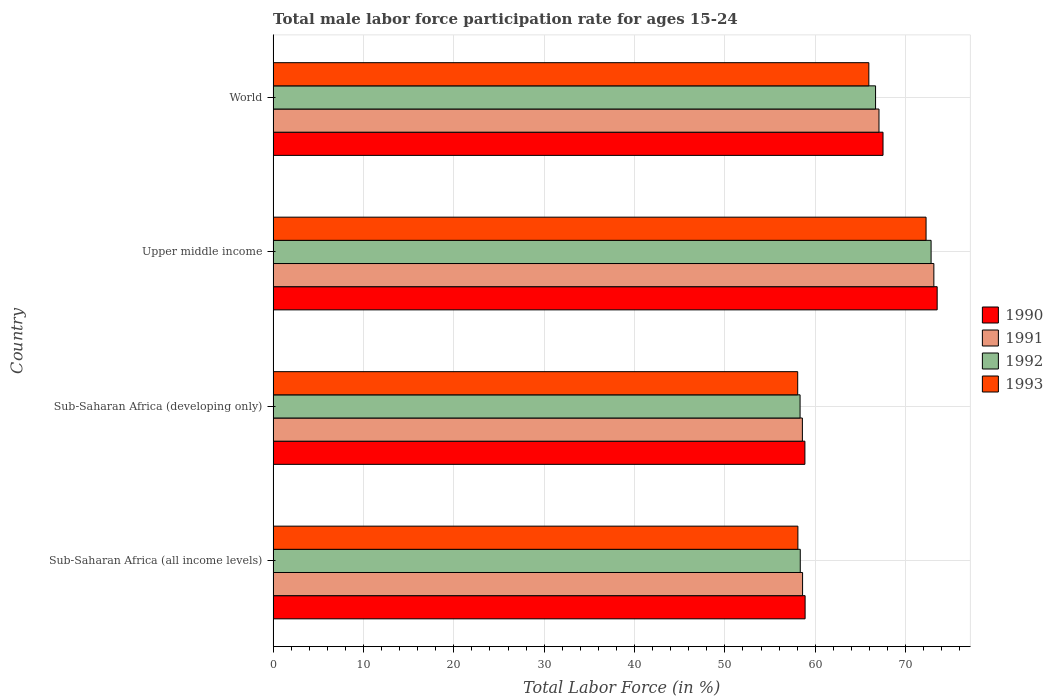How many different coloured bars are there?
Your answer should be very brief. 4. How many groups of bars are there?
Ensure brevity in your answer.  4. Are the number of bars per tick equal to the number of legend labels?
Offer a terse response. Yes. Are the number of bars on each tick of the Y-axis equal?
Your answer should be compact. Yes. How many bars are there on the 1st tick from the top?
Make the answer very short. 4. How many bars are there on the 4th tick from the bottom?
Offer a very short reply. 4. What is the male labor force participation rate in 1990 in Sub-Saharan Africa (all income levels)?
Provide a short and direct response. 58.88. Across all countries, what is the maximum male labor force participation rate in 1990?
Provide a short and direct response. 73.49. Across all countries, what is the minimum male labor force participation rate in 1991?
Keep it short and to the point. 58.57. In which country was the male labor force participation rate in 1993 maximum?
Keep it short and to the point. Upper middle income. In which country was the male labor force participation rate in 1990 minimum?
Keep it short and to the point. Sub-Saharan Africa (developing only). What is the total male labor force participation rate in 1990 in the graph?
Your response must be concise. 258.72. What is the difference between the male labor force participation rate in 1991 in Sub-Saharan Africa (developing only) and that in World?
Provide a succinct answer. -8.48. What is the difference between the male labor force participation rate in 1993 in Sub-Saharan Africa (all income levels) and the male labor force participation rate in 1991 in Upper middle income?
Provide a succinct answer. -15.05. What is the average male labor force participation rate in 1991 per country?
Give a very brief answer. 64.34. What is the difference between the male labor force participation rate in 1990 and male labor force participation rate in 1993 in Sub-Saharan Africa (developing only)?
Ensure brevity in your answer.  0.8. In how many countries, is the male labor force participation rate in 1991 greater than 52 %?
Offer a very short reply. 4. What is the ratio of the male labor force participation rate in 1993 in Sub-Saharan Africa (all income levels) to that in World?
Make the answer very short. 0.88. Is the male labor force participation rate in 1991 in Sub-Saharan Africa (developing only) less than that in World?
Give a very brief answer. Yes. Is the difference between the male labor force participation rate in 1990 in Sub-Saharan Africa (developing only) and World greater than the difference between the male labor force participation rate in 1993 in Sub-Saharan Africa (developing only) and World?
Provide a succinct answer. No. What is the difference between the highest and the second highest male labor force participation rate in 1991?
Give a very brief answer. 6.07. What is the difference between the highest and the lowest male labor force participation rate in 1991?
Give a very brief answer. 14.55. In how many countries, is the male labor force participation rate in 1990 greater than the average male labor force participation rate in 1990 taken over all countries?
Give a very brief answer. 2. What does the 2nd bar from the top in Sub-Saharan Africa (developing only) represents?
Provide a succinct answer. 1992. What does the 2nd bar from the bottom in Sub-Saharan Africa (all income levels) represents?
Make the answer very short. 1991. Is it the case that in every country, the sum of the male labor force participation rate in 1992 and male labor force participation rate in 1991 is greater than the male labor force participation rate in 1990?
Provide a succinct answer. Yes. How many bars are there?
Ensure brevity in your answer.  16. Are all the bars in the graph horizontal?
Offer a very short reply. Yes. How many countries are there in the graph?
Provide a succinct answer. 4. Are the values on the major ticks of X-axis written in scientific E-notation?
Ensure brevity in your answer.  No. How are the legend labels stacked?
Your response must be concise. Vertical. What is the title of the graph?
Make the answer very short. Total male labor force participation rate for ages 15-24. What is the label or title of the X-axis?
Offer a very short reply. Total Labor Force (in %). What is the label or title of the Y-axis?
Make the answer very short. Country. What is the Total Labor Force (in %) in 1990 in Sub-Saharan Africa (all income levels)?
Keep it short and to the point. 58.88. What is the Total Labor Force (in %) of 1991 in Sub-Saharan Africa (all income levels)?
Your answer should be compact. 58.6. What is the Total Labor Force (in %) of 1992 in Sub-Saharan Africa (all income levels)?
Keep it short and to the point. 58.34. What is the Total Labor Force (in %) of 1993 in Sub-Saharan Africa (all income levels)?
Your answer should be very brief. 58.08. What is the Total Labor Force (in %) in 1990 in Sub-Saharan Africa (developing only)?
Your answer should be very brief. 58.85. What is the Total Labor Force (in %) of 1991 in Sub-Saharan Africa (developing only)?
Your response must be concise. 58.57. What is the Total Labor Force (in %) in 1992 in Sub-Saharan Africa (developing only)?
Your answer should be very brief. 58.32. What is the Total Labor Force (in %) of 1993 in Sub-Saharan Africa (developing only)?
Offer a terse response. 58.06. What is the Total Labor Force (in %) of 1990 in Upper middle income?
Your answer should be very brief. 73.49. What is the Total Labor Force (in %) in 1991 in Upper middle income?
Provide a short and direct response. 73.13. What is the Total Labor Force (in %) of 1992 in Upper middle income?
Your answer should be compact. 72.82. What is the Total Labor Force (in %) in 1993 in Upper middle income?
Provide a succinct answer. 72.26. What is the Total Labor Force (in %) of 1990 in World?
Provide a short and direct response. 67.5. What is the Total Labor Force (in %) of 1991 in World?
Keep it short and to the point. 67.05. What is the Total Labor Force (in %) of 1992 in World?
Your answer should be very brief. 66.67. What is the Total Labor Force (in %) of 1993 in World?
Offer a terse response. 65.93. Across all countries, what is the maximum Total Labor Force (in %) of 1990?
Your response must be concise. 73.49. Across all countries, what is the maximum Total Labor Force (in %) in 1991?
Your response must be concise. 73.13. Across all countries, what is the maximum Total Labor Force (in %) in 1992?
Your answer should be very brief. 72.82. Across all countries, what is the maximum Total Labor Force (in %) in 1993?
Make the answer very short. 72.26. Across all countries, what is the minimum Total Labor Force (in %) in 1990?
Offer a terse response. 58.85. Across all countries, what is the minimum Total Labor Force (in %) of 1991?
Provide a succinct answer. 58.57. Across all countries, what is the minimum Total Labor Force (in %) of 1992?
Give a very brief answer. 58.32. Across all countries, what is the minimum Total Labor Force (in %) in 1993?
Offer a very short reply. 58.06. What is the total Total Labor Force (in %) of 1990 in the graph?
Offer a terse response. 258.72. What is the total Total Labor Force (in %) of 1991 in the graph?
Offer a terse response. 257.35. What is the total Total Labor Force (in %) of 1992 in the graph?
Keep it short and to the point. 256.15. What is the total Total Labor Force (in %) of 1993 in the graph?
Offer a very short reply. 254.33. What is the difference between the Total Labor Force (in %) of 1990 in Sub-Saharan Africa (all income levels) and that in Sub-Saharan Africa (developing only)?
Make the answer very short. 0.02. What is the difference between the Total Labor Force (in %) of 1991 in Sub-Saharan Africa (all income levels) and that in Sub-Saharan Africa (developing only)?
Keep it short and to the point. 0.02. What is the difference between the Total Labor Force (in %) in 1992 in Sub-Saharan Africa (all income levels) and that in Sub-Saharan Africa (developing only)?
Offer a very short reply. 0.02. What is the difference between the Total Labor Force (in %) of 1993 in Sub-Saharan Africa (all income levels) and that in Sub-Saharan Africa (developing only)?
Make the answer very short. 0.02. What is the difference between the Total Labor Force (in %) in 1990 in Sub-Saharan Africa (all income levels) and that in Upper middle income?
Provide a short and direct response. -14.62. What is the difference between the Total Labor Force (in %) in 1991 in Sub-Saharan Africa (all income levels) and that in Upper middle income?
Ensure brevity in your answer.  -14.53. What is the difference between the Total Labor Force (in %) of 1992 in Sub-Saharan Africa (all income levels) and that in Upper middle income?
Offer a very short reply. -14.48. What is the difference between the Total Labor Force (in %) of 1993 in Sub-Saharan Africa (all income levels) and that in Upper middle income?
Provide a short and direct response. -14.19. What is the difference between the Total Labor Force (in %) in 1990 in Sub-Saharan Africa (all income levels) and that in World?
Your answer should be compact. -8.62. What is the difference between the Total Labor Force (in %) of 1991 in Sub-Saharan Africa (all income levels) and that in World?
Your response must be concise. -8.46. What is the difference between the Total Labor Force (in %) in 1992 in Sub-Saharan Africa (all income levels) and that in World?
Your answer should be very brief. -8.33. What is the difference between the Total Labor Force (in %) of 1993 in Sub-Saharan Africa (all income levels) and that in World?
Keep it short and to the point. -7.85. What is the difference between the Total Labor Force (in %) in 1990 in Sub-Saharan Africa (developing only) and that in Upper middle income?
Give a very brief answer. -14.64. What is the difference between the Total Labor Force (in %) in 1991 in Sub-Saharan Africa (developing only) and that in Upper middle income?
Provide a succinct answer. -14.55. What is the difference between the Total Labor Force (in %) in 1992 in Sub-Saharan Africa (developing only) and that in Upper middle income?
Your answer should be compact. -14.5. What is the difference between the Total Labor Force (in %) of 1993 in Sub-Saharan Africa (developing only) and that in Upper middle income?
Ensure brevity in your answer.  -14.21. What is the difference between the Total Labor Force (in %) in 1990 in Sub-Saharan Africa (developing only) and that in World?
Your answer should be compact. -8.65. What is the difference between the Total Labor Force (in %) of 1991 in Sub-Saharan Africa (developing only) and that in World?
Provide a succinct answer. -8.48. What is the difference between the Total Labor Force (in %) of 1992 in Sub-Saharan Africa (developing only) and that in World?
Ensure brevity in your answer.  -8.35. What is the difference between the Total Labor Force (in %) in 1993 in Sub-Saharan Africa (developing only) and that in World?
Give a very brief answer. -7.87. What is the difference between the Total Labor Force (in %) of 1990 in Upper middle income and that in World?
Provide a succinct answer. 5.99. What is the difference between the Total Labor Force (in %) of 1991 in Upper middle income and that in World?
Offer a very short reply. 6.07. What is the difference between the Total Labor Force (in %) of 1992 in Upper middle income and that in World?
Your answer should be compact. 6.15. What is the difference between the Total Labor Force (in %) of 1993 in Upper middle income and that in World?
Keep it short and to the point. 6.33. What is the difference between the Total Labor Force (in %) in 1990 in Sub-Saharan Africa (all income levels) and the Total Labor Force (in %) in 1991 in Sub-Saharan Africa (developing only)?
Provide a succinct answer. 0.3. What is the difference between the Total Labor Force (in %) in 1990 in Sub-Saharan Africa (all income levels) and the Total Labor Force (in %) in 1992 in Sub-Saharan Africa (developing only)?
Your answer should be compact. 0.56. What is the difference between the Total Labor Force (in %) in 1990 in Sub-Saharan Africa (all income levels) and the Total Labor Force (in %) in 1993 in Sub-Saharan Africa (developing only)?
Give a very brief answer. 0.82. What is the difference between the Total Labor Force (in %) of 1991 in Sub-Saharan Africa (all income levels) and the Total Labor Force (in %) of 1992 in Sub-Saharan Africa (developing only)?
Ensure brevity in your answer.  0.28. What is the difference between the Total Labor Force (in %) of 1991 in Sub-Saharan Africa (all income levels) and the Total Labor Force (in %) of 1993 in Sub-Saharan Africa (developing only)?
Your answer should be very brief. 0.54. What is the difference between the Total Labor Force (in %) of 1992 in Sub-Saharan Africa (all income levels) and the Total Labor Force (in %) of 1993 in Sub-Saharan Africa (developing only)?
Your answer should be compact. 0.28. What is the difference between the Total Labor Force (in %) in 1990 in Sub-Saharan Africa (all income levels) and the Total Labor Force (in %) in 1991 in Upper middle income?
Make the answer very short. -14.25. What is the difference between the Total Labor Force (in %) in 1990 in Sub-Saharan Africa (all income levels) and the Total Labor Force (in %) in 1992 in Upper middle income?
Offer a very short reply. -13.94. What is the difference between the Total Labor Force (in %) of 1990 in Sub-Saharan Africa (all income levels) and the Total Labor Force (in %) of 1993 in Upper middle income?
Ensure brevity in your answer.  -13.39. What is the difference between the Total Labor Force (in %) of 1991 in Sub-Saharan Africa (all income levels) and the Total Labor Force (in %) of 1992 in Upper middle income?
Your answer should be compact. -14.22. What is the difference between the Total Labor Force (in %) of 1991 in Sub-Saharan Africa (all income levels) and the Total Labor Force (in %) of 1993 in Upper middle income?
Your answer should be very brief. -13.67. What is the difference between the Total Labor Force (in %) in 1992 in Sub-Saharan Africa (all income levels) and the Total Labor Force (in %) in 1993 in Upper middle income?
Give a very brief answer. -13.92. What is the difference between the Total Labor Force (in %) of 1990 in Sub-Saharan Africa (all income levels) and the Total Labor Force (in %) of 1991 in World?
Your response must be concise. -8.18. What is the difference between the Total Labor Force (in %) of 1990 in Sub-Saharan Africa (all income levels) and the Total Labor Force (in %) of 1992 in World?
Offer a terse response. -7.8. What is the difference between the Total Labor Force (in %) of 1990 in Sub-Saharan Africa (all income levels) and the Total Labor Force (in %) of 1993 in World?
Your answer should be compact. -7.05. What is the difference between the Total Labor Force (in %) in 1991 in Sub-Saharan Africa (all income levels) and the Total Labor Force (in %) in 1992 in World?
Your response must be concise. -8.08. What is the difference between the Total Labor Force (in %) of 1991 in Sub-Saharan Africa (all income levels) and the Total Labor Force (in %) of 1993 in World?
Make the answer very short. -7.33. What is the difference between the Total Labor Force (in %) of 1992 in Sub-Saharan Africa (all income levels) and the Total Labor Force (in %) of 1993 in World?
Offer a terse response. -7.59. What is the difference between the Total Labor Force (in %) in 1990 in Sub-Saharan Africa (developing only) and the Total Labor Force (in %) in 1991 in Upper middle income?
Your response must be concise. -14.27. What is the difference between the Total Labor Force (in %) of 1990 in Sub-Saharan Africa (developing only) and the Total Labor Force (in %) of 1992 in Upper middle income?
Give a very brief answer. -13.97. What is the difference between the Total Labor Force (in %) in 1990 in Sub-Saharan Africa (developing only) and the Total Labor Force (in %) in 1993 in Upper middle income?
Keep it short and to the point. -13.41. What is the difference between the Total Labor Force (in %) of 1991 in Sub-Saharan Africa (developing only) and the Total Labor Force (in %) of 1992 in Upper middle income?
Ensure brevity in your answer.  -14.24. What is the difference between the Total Labor Force (in %) in 1991 in Sub-Saharan Africa (developing only) and the Total Labor Force (in %) in 1993 in Upper middle income?
Give a very brief answer. -13.69. What is the difference between the Total Labor Force (in %) in 1992 in Sub-Saharan Africa (developing only) and the Total Labor Force (in %) in 1993 in Upper middle income?
Provide a succinct answer. -13.94. What is the difference between the Total Labor Force (in %) of 1990 in Sub-Saharan Africa (developing only) and the Total Labor Force (in %) of 1991 in World?
Ensure brevity in your answer.  -8.2. What is the difference between the Total Labor Force (in %) in 1990 in Sub-Saharan Africa (developing only) and the Total Labor Force (in %) in 1992 in World?
Ensure brevity in your answer.  -7.82. What is the difference between the Total Labor Force (in %) in 1990 in Sub-Saharan Africa (developing only) and the Total Labor Force (in %) in 1993 in World?
Provide a short and direct response. -7.08. What is the difference between the Total Labor Force (in %) of 1991 in Sub-Saharan Africa (developing only) and the Total Labor Force (in %) of 1992 in World?
Make the answer very short. -8.1. What is the difference between the Total Labor Force (in %) in 1991 in Sub-Saharan Africa (developing only) and the Total Labor Force (in %) in 1993 in World?
Provide a short and direct response. -7.36. What is the difference between the Total Labor Force (in %) in 1992 in Sub-Saharan Africa (developing only) and the Total Labor Force (in %) in 1993 in World?
Your answer should be very brief. -7.61. What is the difference between the Total Labor Force (in %) in 1990 in Upper middle income and the Total Labor Force (in %) in 1991 in World?
Offer a very short reply. 6.44. What is the difference between the Total Labor Force (in %) of 1990 in Upper middle income and the Total Labor Force (in %) of 1992 in World?
Your answer should be very brief. 6.82. What is the difference between the Total Labor Force (in %) of 1990 in Upper middle income and the Total Labor Force (in %) of 1993 in World?
Your answer should be compact. 7.56. What is the difference between the Total Labor Force (in %) in 1991 in Upper middle income and the Total Labor Force (in %) in 1992 in World?
Your response must be concise. 6.45. What is the difference between the Total Labor Force (in %) of 1991 in Upper middle income and the Total Labor Force (in %) of 1993 in World?
Give a very brief answer. 7.2. What is the difference between the Total Labor Force (in %) in 1992 in Upper middle income and the Total Labor Force (in %) in 1993 in World?
Give a very brief answer. 6.89. What is the average Total Labor Force (in %) in 1990 per country?
Offer a very short reply. 64.68. What is the average Total Labor Force (in %) of 1991 per country?
Keep it short and to the point. 64.34. What is the average Total Labor Force (in %) in 1992 per country?
Offer a terse response. 64.04. What is the average Total Labor Force (in %) of 1993 per country?
Offer a very short reply. 63.58. What is the difference between the Total Labor Force (in %) of 1990 and Total Labor Force (in %) of 1991 in Sub-Saharan Africa (all income levels)?
Keep it short and to the point. 0.28. What is the difference between the Total Labor Force (in %) in 1990 and Total Labor Force (in %) in 1992 in Sub-Saharan Africa (all income levels)?
Offer a very short reply. 0.53. What is the difference between the Total Labor Force (in %) of 1990 and Total Labor Force (in %) of 1993 in Sub-Saharan Africa (all income levels)?
Your response must be concise. 0.8. What is the difference between the Total Labor Force (in %) in 1991 and Total Labor Force (in %) in 1992 in Sub-Saharan Africa (all income levels)?
Offer a terse response. 0.26. What is the difference between the Total Labor Force (in %) of 1991 and Total Labor Force (in %) of 1993 in Sub-Saharan Africa (all income levels)?
Offer a terse response. 0.52. What is the difference between the Total Labor Force (in %) in 1992 and Total Labor Force (in %) in 1993 in Sub-Saharan Africa (all income levels)?
Your answer should be very brief. 0.26. What is the difference between the Total Labor Force (in %) of 1990 and Total Labor Force (in %) of 1991 in Sub-Saharan Africa (developing only)?
Provide a succinct answer. 0.28. What is the difference between the Total Labor Force (in %) in 1990 and Total Labor Force (in %) in 1992 in Sub-Saharan Africa (developing only)?
Your answer should be compact. 0.53. What is the difference between the Total Labor Force (in %) of 1990 and Total Labor Force (in %) of 1993 in Sub-Saharan Africa (developing only)?
Provide a succinct answer. 0.8. What is the difference between the Total Labor Force (in %) of 1991 and Total Labor Force (in %) of 1992 in Sub-Saharan Africa (developing only)?
Ensure brevity in your answer.  0.25. What is the difference between the Total Labor Force (in %) in 1991 and Total Labor Force (in %) in 1993 in Sub-Saharan Africa (developing only)?
Make the answer very short. 0.52. What is the difference between the Total Labor Force (in %) of 1992 and Total Labor Force (in %) of 1993 in Sub-Saharan Africa (developing only)?
Give a very brief answer. 0.26. What is the difference between the Total Labor Force (in %) in 1990 and Total Labor Force (in %) in 1991 in Upper middle income?
Give a very brief answer. 0.37. What is the difference between the Total Labor Force (in %) of 1990 and Total Labor Force (in %) of 1992 in Upper middle income?
Offer a terse response. 0.67. What is the difference between the Total Labor Force (in %) of 1990 and Total Labor Force (in %) of 1993 in Upper middle income?
Keep it short and to the point. 1.23. What is the difference between the Total Labor Force (in %) in 1991 and Total Labor Force (in %) in 1992 in Upper middle income?
Your response must be concise. 0.31. What is the difference between the Total Labor Force (in %) in 1991 and Total Labor Force (in %) in 1993 in Upper middle income?
Provide a succinct answer. 0.86. What is the difference between the Total Labor Force (in %) of 1992 and Total Labor Force (in %) of 1993 in Upper middle income?
Ensure brevity in your answer.  0.56. What is the difference between the Total Labor Force (in %) in 1990 and Total Labor Force (in %) in 1991 in World?
Give a very brief answer. 0.45. What is the difference between the Total Labor Force (in %) in 1990 and Total Labor Force (in %) in 1992 in World?
Offer a very short reply. 0.83. What is the difference between the Total Labor Force (in %) in 1990 and Total Labor Force (in %) in 1993 in World?
Provide a succinct answer. 1.57. What is the difference between the Total Labor Force (in %) in 1991 and Total Labor Force (in %) in 1992 in World?
Offer a terse response. 0.38. What is the difference between the Total Labor Force (in %) of 1991 and Total Labor Force (in %) of 1993 in World?
Offer a very short reply. 1.12. What is the difference between the Total Labor Force (in %) of 1992 and Total Labor Force (in %) of 1993 in World?
Make the answer very short. 0.74. What is the ratio of the Total Labor Force (in %) in 1990 in Sub-Saharan Africa (all income levels) to that in Sub-Saharan Africa (developing only)?
Offer a terse response. 1. What is the ratio of the Total Labor Force (in %) in 1992 in Sub-Saharan Africa (all income levels) to that in Sub-Saharan Africa (developing only)?
Ensure brevity in your answer.  1. What is the ratio of the Total Labor Force (in %) in 1990 in Sub-Saharan Africa (all income levels) to that in Upper middle income?
Your answer should be compact. 0.8. What is the ratio of the Total Labor Force (in %) of 1991 in Sub-Saharan Africa (all income levels) to that in Upper middle income?
Offer a very short reply. 0.8. What is the ratio of the Total Labor Force (in %) in 1992 in Sub-Saharan Africa (all income levels) to that in Upper middle income?
Provide a short and direct response. 0.8. What is the ratio of the Total Labor Force (in %) of 1993 in Sub-Saharan Africa (all income levels) to that in Upper middle income?
Give a very brief answer. 0.8. What is the ratio of the Total Labor Force (in %) in 1990 in Sub-Saharan Africa (all income levels) to that in World?
Provide a succinct answer. 0.87. What is the ratio of the Total Labor Force (in %) in 1991 in Sub-Saharan Africa (all income levels) to that in World?
Your answer should be very brief. 0.87. What is the ratio of the Total Labor Force (in %) of 1993 in Sub-Saharan Africa (all income levels) to that in World?
Your response must be concise. 0.88. What is the ratio of the Total Labor Force (in %) in 1990 in Sub-Saharan Africa (developing only) to that in Upper middle income?
Provide a short and direct response. 0.8. What is the ratio of the Total Labor Force (in %) of 1991 in Sub-Saharan Africa (developing only) to that in Upper middle income?
Provide a succinct answer. 0.8. What is the ratio of the Total Labor Force (in %) in 1992 in Sub-Saharan Africa (developing only) to that in Upper middle income?
Offer a terse response. 0.8. What is the ratio of the Total Labor Force (in %) of 1993 in Sub-Saharan Africa (developing only) to that in Upper middle income?
Offer a very short reply. 0.8. What is the ratio of the Total Labor Force (in %) in 1990 in Sub-Saharan Africa (developing only) to that in World?
Your response must be concise. 0.87. What is the ratio of the Total Labor Force (in %) of 1991 in Sub-Saharan Africa (developing only) to that in World?
Ensure brevity in your answer.  0.87. What is the ratio of the Total Labor Force (in %) in 1992 in Sub-Saharan Africa (developing only) to that in World?
Keep it short and to the point. 0.87. What is the ratio of the Total Labor Force (in %) in 1993 in Sub-Saharan Africa (developing only) to that in World?
Your response must be concise. 0.88. What is the ratio of the Total Labor Force (in %) in 1990 in Upper middle income to that in World?
Your answer should be compact. 1.09. What is the ratio of the Total Labor Force (in %) in 1991 in Upper middle income to that in World?
Provide a succinct answer. 1.09. What is the ratio of the Total Labor Force (in %) in 1992 in Upper middle income to that in World?
Provide a short and direct response. 1.09. What is the ratio of the Total Labor Force (in %) of 1993 in Upper middle income to that in World?
Offer a very short reply. 1.1. What is the difference between the highest and the second highest Total Labor Force (in %) in 1990?
Ensure brevity in your answer.  5.99. What is the difference between the highest and the second highest Total Labor Force (in %) in 1991?
Your answer should be very brief. 6.07. What is the difference between the highest and the second highest Total Labor Force (in %) in 1992?
Make the answer very short. 6.15. What is the difference between the highest and the second highest Total Labor Force (in %) of 1993?
Your response must be concise. 6.33. What is the difference between the highest and the lowest Total Labor Force (in %) in 1990?
Give a very brief answer. 14.64. What is the difference between the highest and the lowest Total Labor Force (in %) of 1991?
Your response must be concise. 14.55. What is the difference between the highest and the lowest Total Labor Force (in %) in 1992?
Ensure brevity in your answer.  14.5. What is the difference between the highest and the lowest Total Labor Force (in %) in 1993?
Ensure brevity in your answer.  14.21. 